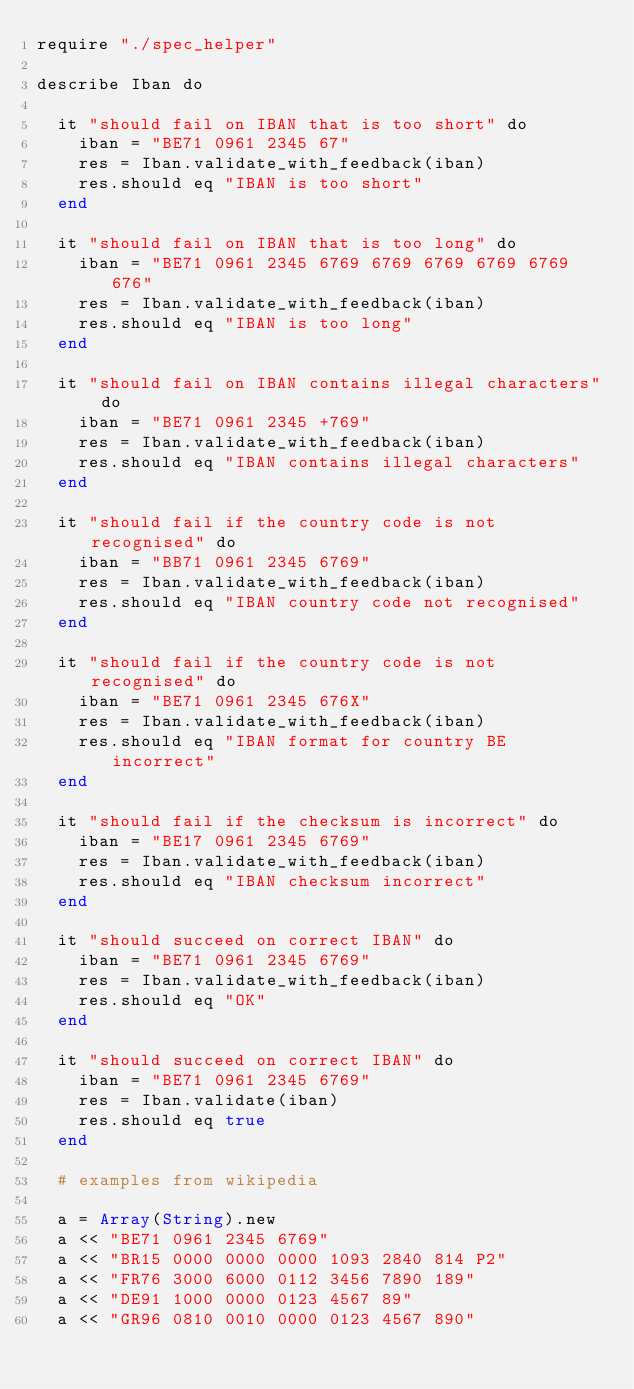Convert code to text. <code><loc_0><loc_0><loc_500><loc_500><_Crystal_>require "./spec_helper"

describe Iban do

  it "should fail on IBAN that is too short" do
    iban = "BE71 0961 2345 67"
    res = Iban.validate_with_feedback(iban)
    res.should eq "IBAN is too short"
  end
    
  it "should fail on IBAN that is too long" do
    iban = "BE71 0961 2345 6769 6769 6769 6769 6769 676"
    res = Iban.validate_with_feedback(iban)
    res.should eq "IBAN is too long"
  end

  it "should fail on IBAN contains illegal characters" do
    iban = "BE71 0961 2345 +769"
    res = Iban.validate_with_feedback(iban)
    res.should eq "IBAN contains illegal characters"
  end

  it "should fail if the country code is not recognised" do
    iban = "BB71 0961 2345 6769"
    res = Iban.validate_with_feedback(iban)
    res.should eq "IBAN country code not recognised"
  end

  it "should fail if the country code is not recognised" do
    iban = "BE71 0961 2345 676X"
    res = Iban.validate_with_feedback(iban)
    res.should eq "IBAN format for country BE incorrect"
  end

  it "should fail if the checksum is incorrect" do
    iban = "BE17 0961 2345 6769"
    res = Iban.validate_with_feedback(iban)
    res.should eq "IBAN checksum incorrect"
  end

  it "should succeed on correct IBAN" do
    iban = "BE71 0961 2345 6769"
    res = Iban.validate_with_feedback(iban)
    res.should eq "OK"
  end
  
  it "should succeed on correct IBAN" do
    iban = "BE71 0961 2345 6769"
    res = Iban.validate(iban)
    res.should eq true
  end

  # examples from wikipedia

  a = Array(String).new
  a << "BE71 0961 2345 6769"
  a << "BR15 0000 0000 0000 1093 2840 814 P2"
  a << "FR76 3000 6000 0112 3456 7890 189"
  a << "DE91 1000 0000 0123 4567 89"
  a << "GR96 0810 0010 0000 0123 4567 890"</code> 